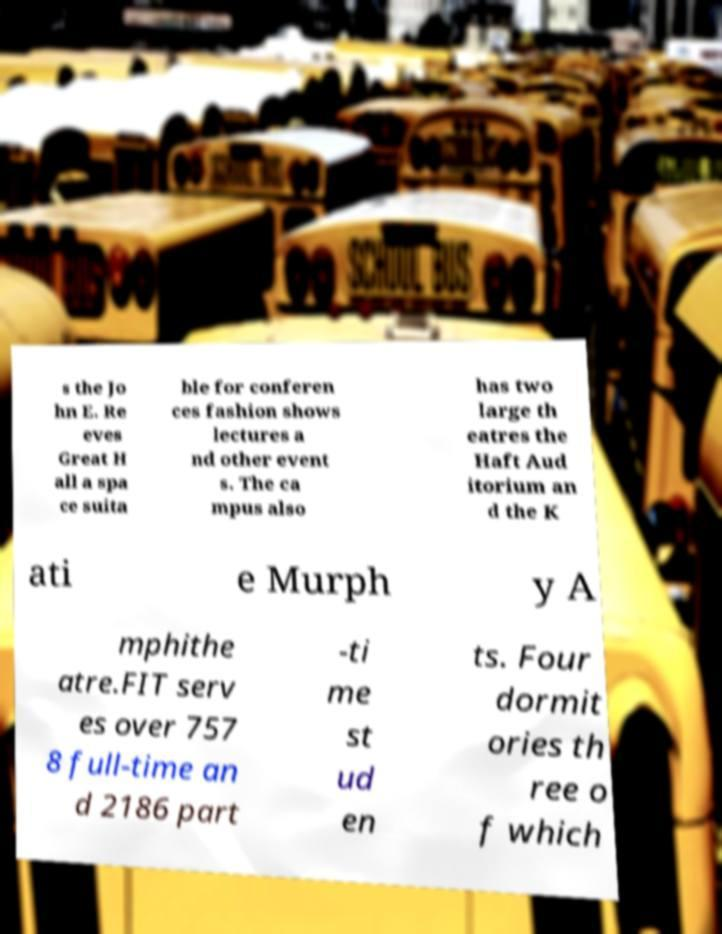There's text embedded in this image that I need extracted. Can you transcribe it verbatim? s the Jo hn E. Re eves Great H all a spa ce suita ble for conferen ces fashion shows lectures a nd other event s. The ca mpus also has two large th eatres the Haft Aud itorium an d the K ati e Murph y A mphithe atre.FIT serv es over 757 8 full-time an d 2186 part -ti me st ud en ts. Four dormit ories th ree o f which 